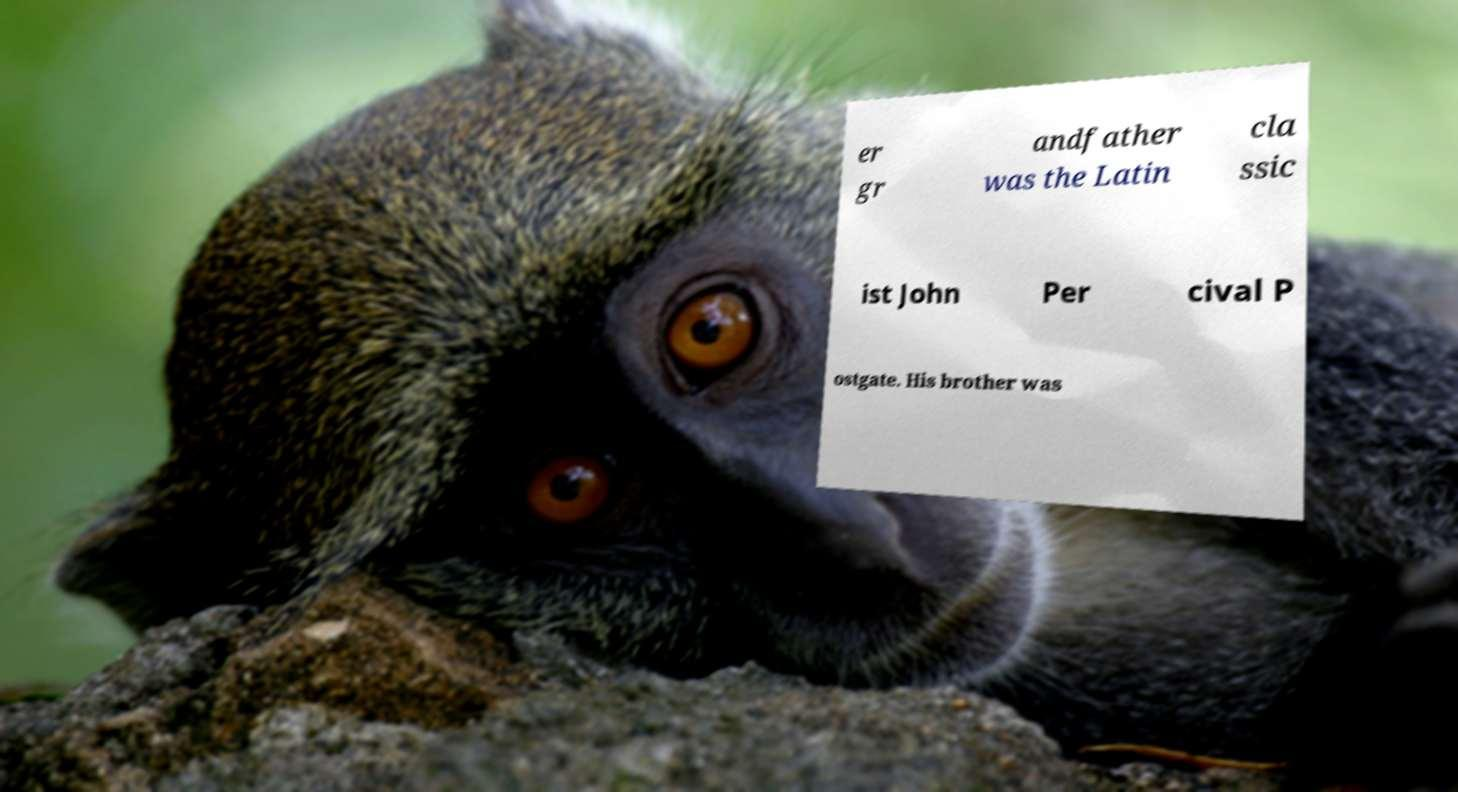For documentation purposes, I need the text within this image transcribed. Could you provide that? er gr andfather was the Latin cla ssic ist John Per cival P ostgate. His brother was 